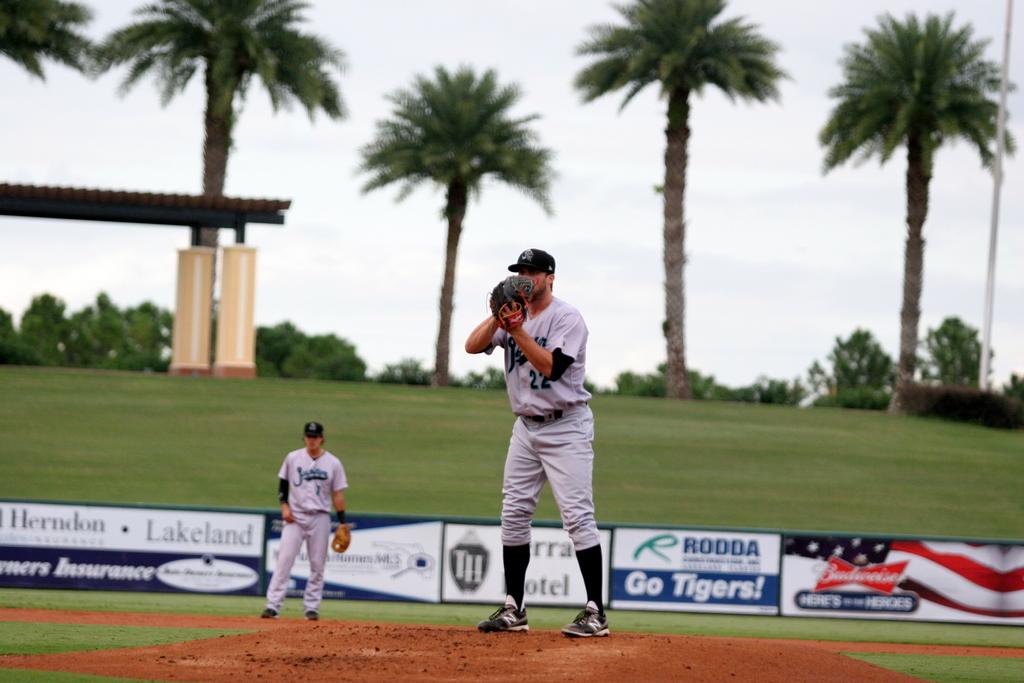Is budweiser a sponsor?
Make the answer very short. Yes. 